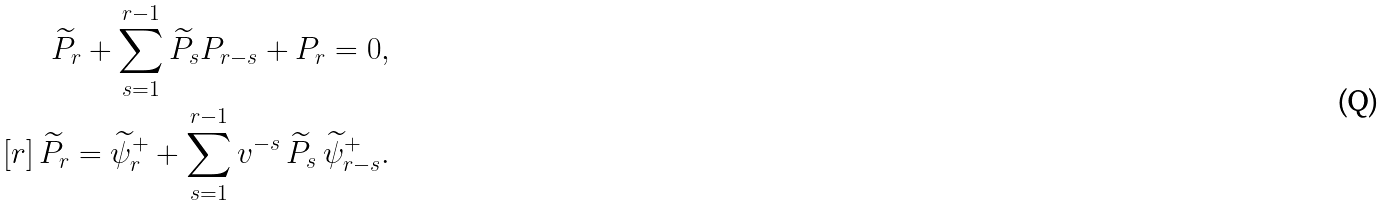<formula> <loc_0><loc_0><loc_500><loc_500>\widetilde { P } _ { r } + \sum _ { s = 1 } ^ { r - 1 } \widetilde { P } _ { s } P _ { r - s } + P _ { r } = 0 , \\ [ r ] \, \widetilde { P } _ { r } = \widetilde { \psi } _ { r } ^ { + } + \sum _ { s = 1 } ^ { r - 1 } v ^ { - s } \, \widetilde { P } _ { s } \, \widetilde { \psi } _ { r - s } ^ { + } .</formula> 